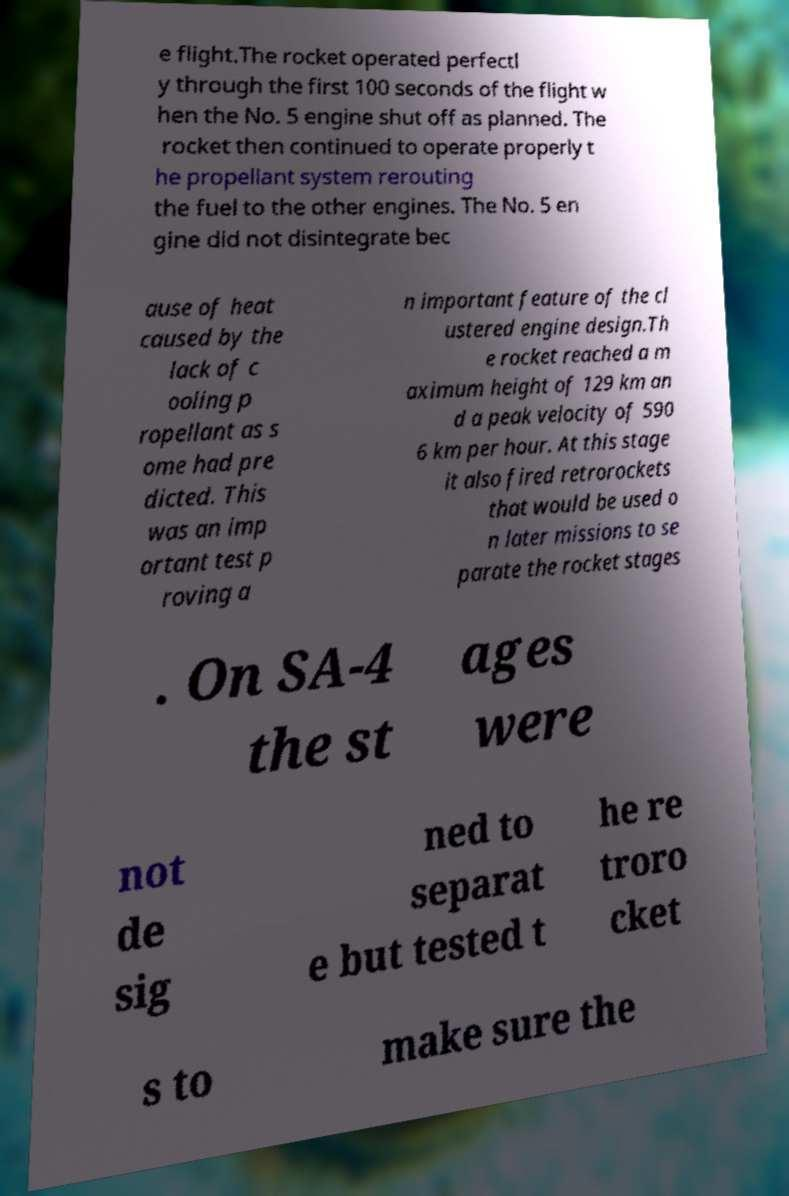There's text embedded in this image that I need extracted. Can you transcribe it verbatim? e flight.The rocket operated perfectl y through the first 100 seconds of the flight w hen the No. 5 engine shut off as planned. The rocket then continued to operate properly t he propellant system rerouting the fuel to the other engines. The No. 5 en gine did not disintegrate bec ause of heat caused by the lack of c ooling p ropellant as s ome had pre dicted. This was an imp ortant test p roving a n important feature of the cl ustered engine design.Th e rocket reached a m aximum height of 129 km an d a peak velocity of 590 6 km per hour. At this stage it also fired retrorockets that would be used o n later missions to se parate the rocket stages . On SA-4 the st ages were not de sig ned to separat e but tested t he re troro cket s to make sure the 